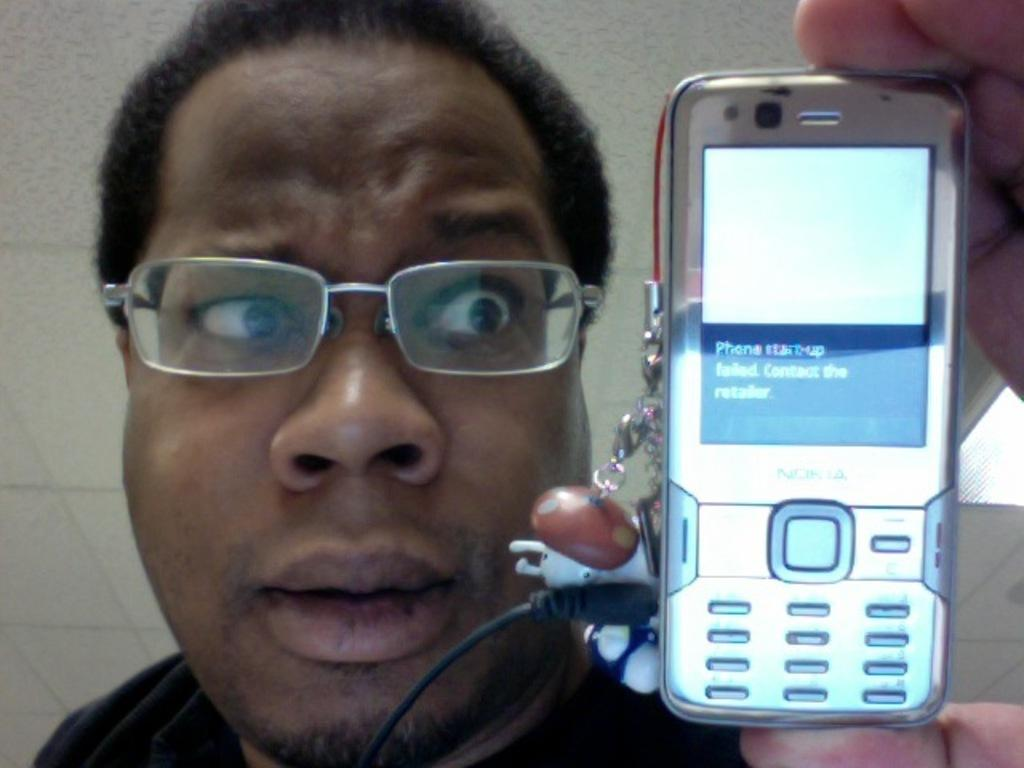Who or what is present in the image? There is a person in the image. What is the person doing or looking at? The person is looking at a mobile. What can be seen behind the person? There is a wall in the background of the image. What type of string is being used to hold the donkey in the image? There is no donkey present in the image, and therefore no string or need to hold a donkey. 